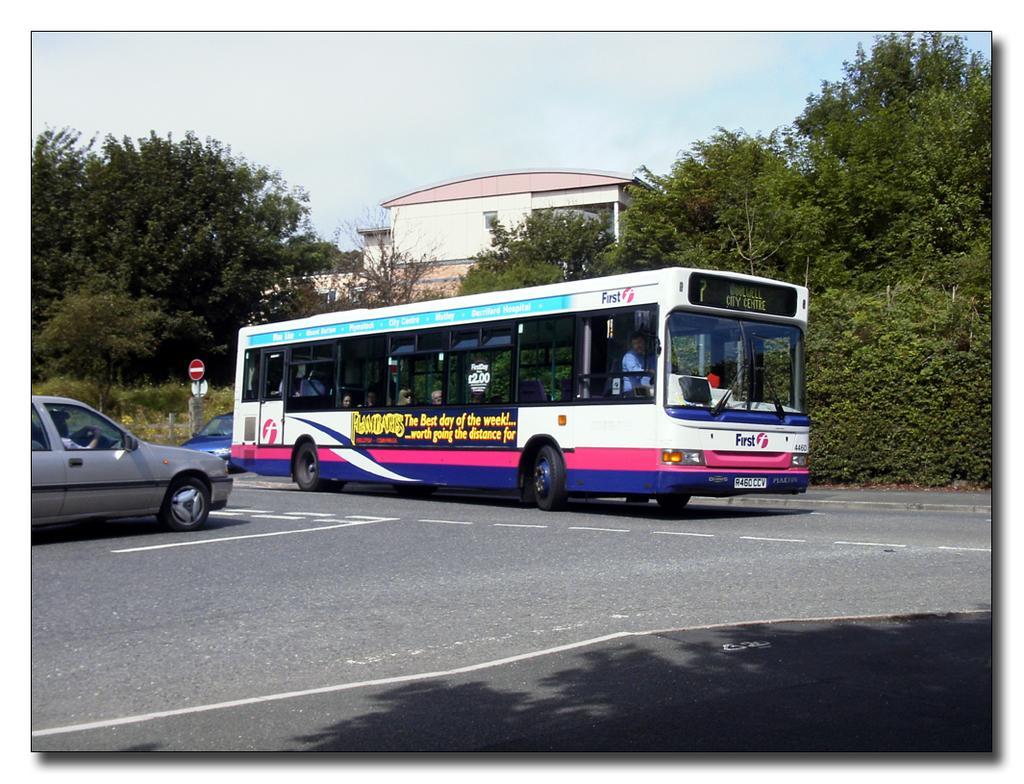Can you describe this image briefly? In this image we can see a bus on the road. Also there are cars. And there is a sign board. In the back there are trees and a building. In the background there is sky. On the bus there is something written. 